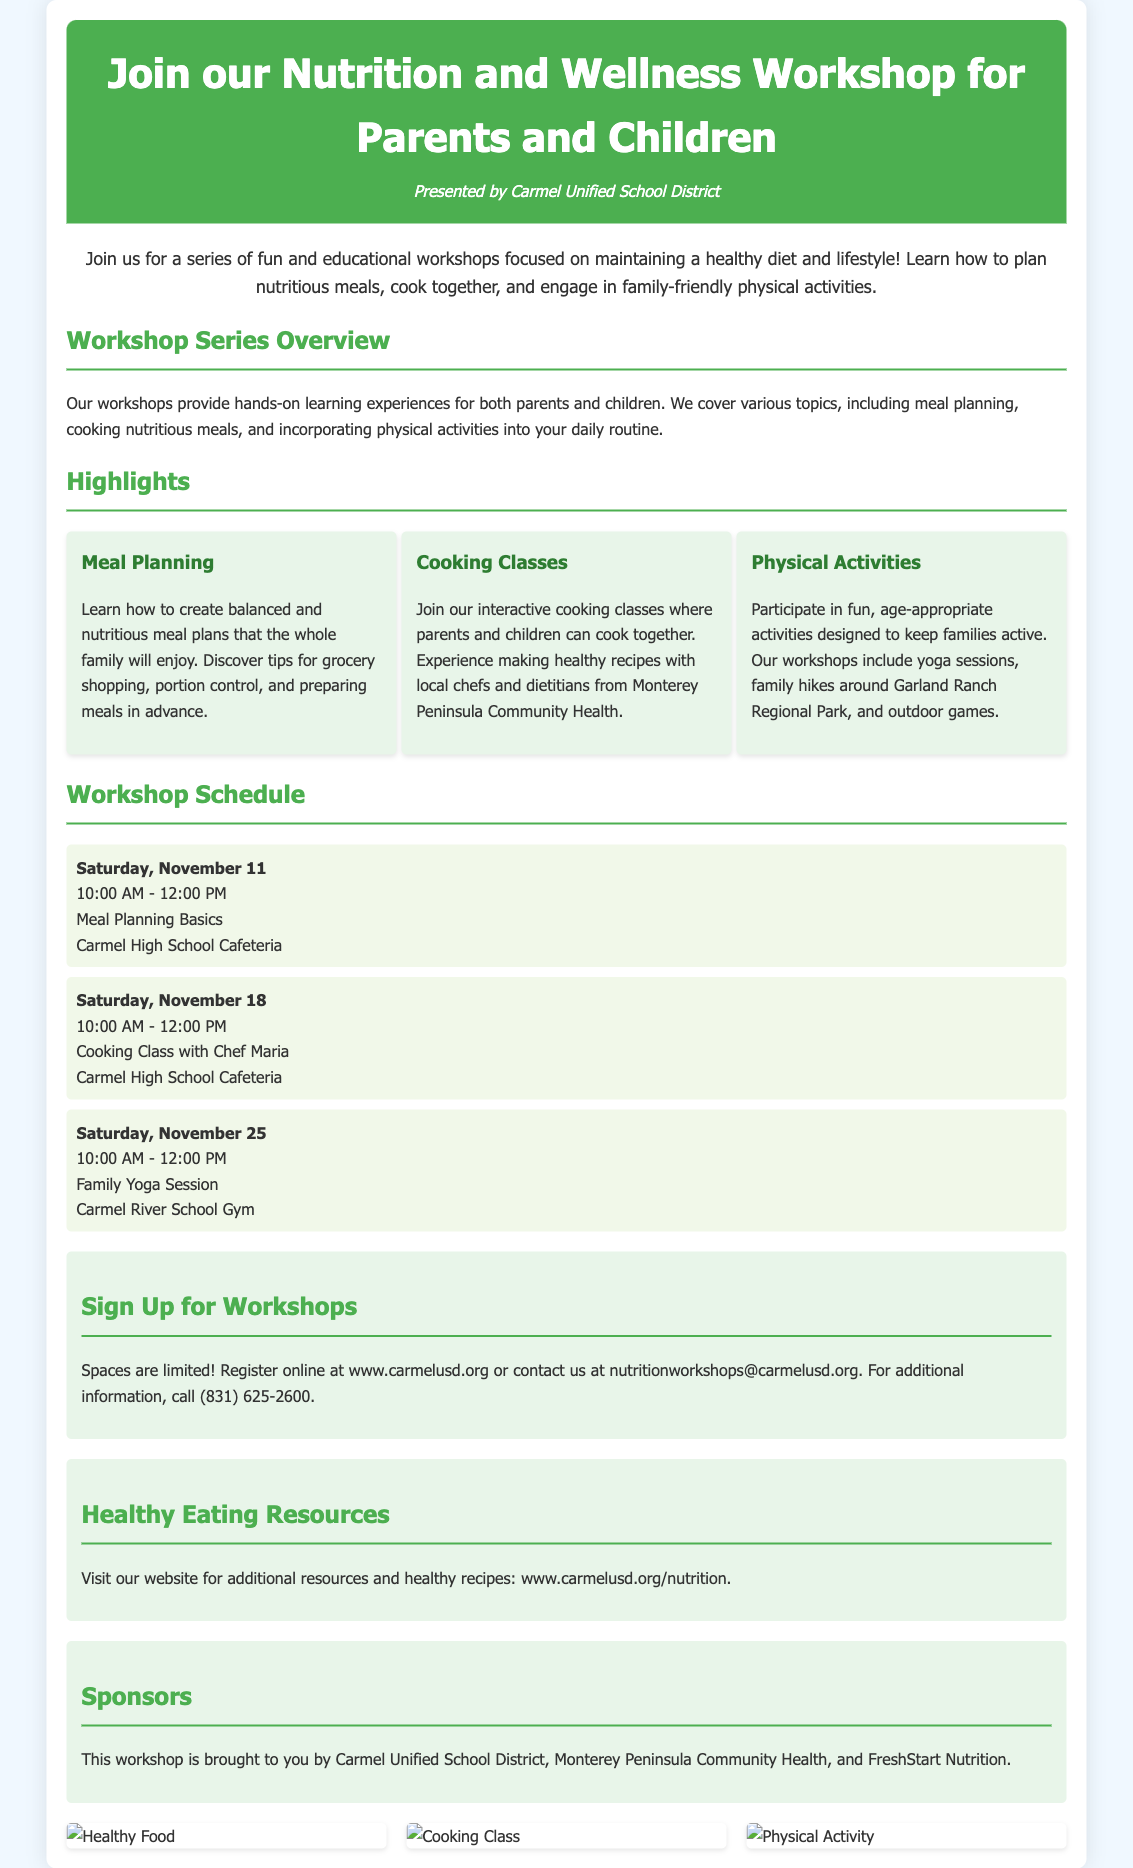What is the title of the workshop? The title of the workshop is prominently displayed at the top of the document.
Answer: Nutrition and Wellness Workshop for Parents and Children Who presented the workshop? The document includes the name of the organization presenting the workshop.
Answer: Carmel Unified School District What is the date of the first workshop? The schedule section lists the date of the first workshop among other details.
Answer: Saturday, November 11 What is the location of the cooking class workshop? The schedule item specifies where the cooking class will take place.
Answer: Carmel High School Cafeteria What are the three main highlights of the workshop? The highlights section lists the key components of the workshop for focus areas.
Answer: Meal Planning, Cooking Classes, Physical Activities How can parents sign up for the workshops? The sign-up section provides explicit instructions on how to register.
Answer: Register online at www.carmelusd.org What is the email address provided for additional contact? The document mentions an email address for inquiries about the workshops.
Answer: nutritionworkshops@carmelusd.org Which organizations sponsored the workshop? The sponsors section identifies the organizations involved in sponsoring the event.
Answer: Carmel Unified School District, Monterey Peninsula Community Health, FreshStart Nutrition 